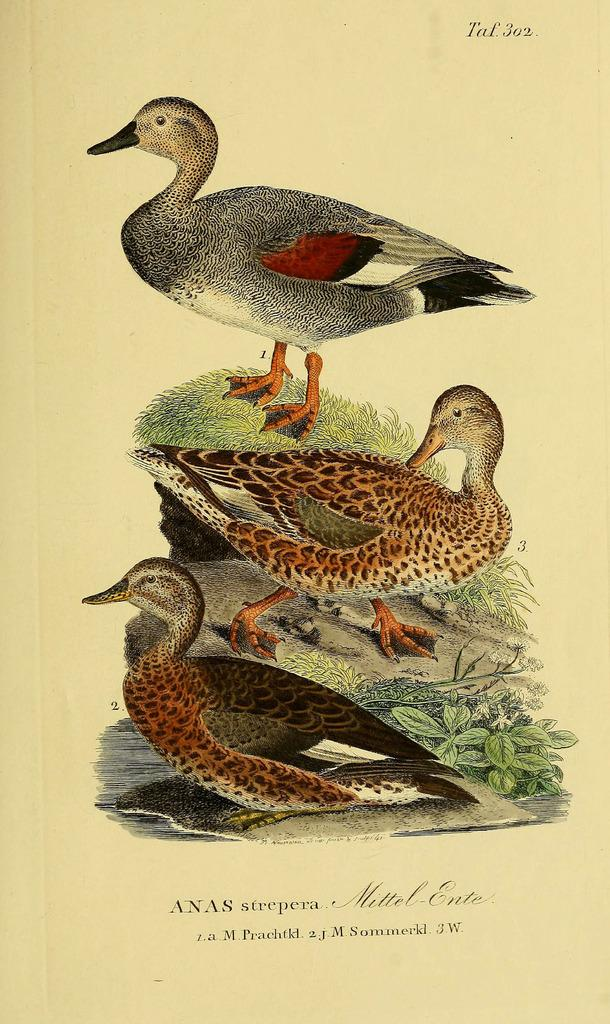How many ducks are present in the image? There are three ducks in the image. What other objects or features can be seen in the image? There is a rock, plants, and grass visible in the image. Is there any text present in the image? Yes, there is text written at the bottom of the image. Where is the dock located in the image? There is no dock present in the image. What type of basket can be seen in the image? There is no basket present in the image. 